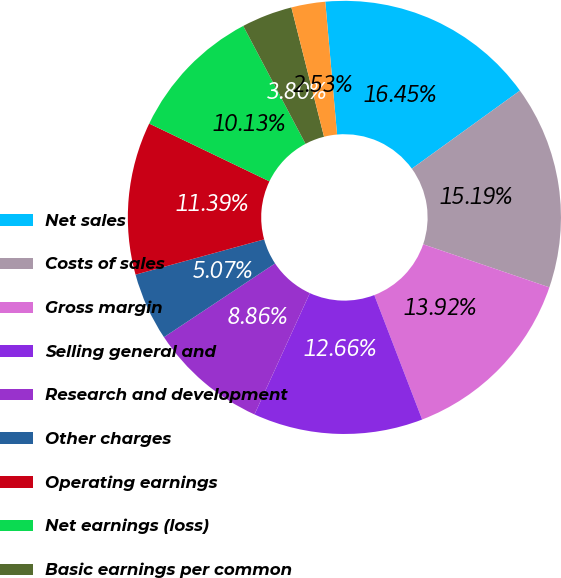<chart> <loc_0><loc_0><loc_500><loc_500><pie_chart><fcel>Net sales<fcel>Costs of sales<fcel>Gross margin<fcel>Selling general and<fcel>Research and development<fcel>Other charges<fcel>Operating earnings<fcel>Net earnings (loss)<fcel>Basic earnings per common<fcel>Diluted earnings per common<nl><fcel>16.45%<fcel>15.19%<fcel>13.92%<fcel>12.66%<fcel>8.86%<fcel>5.07%<fcel>11.39%<fcel>10.13%<fcel>3.8%<fcel>2.53%<nl></chart> 